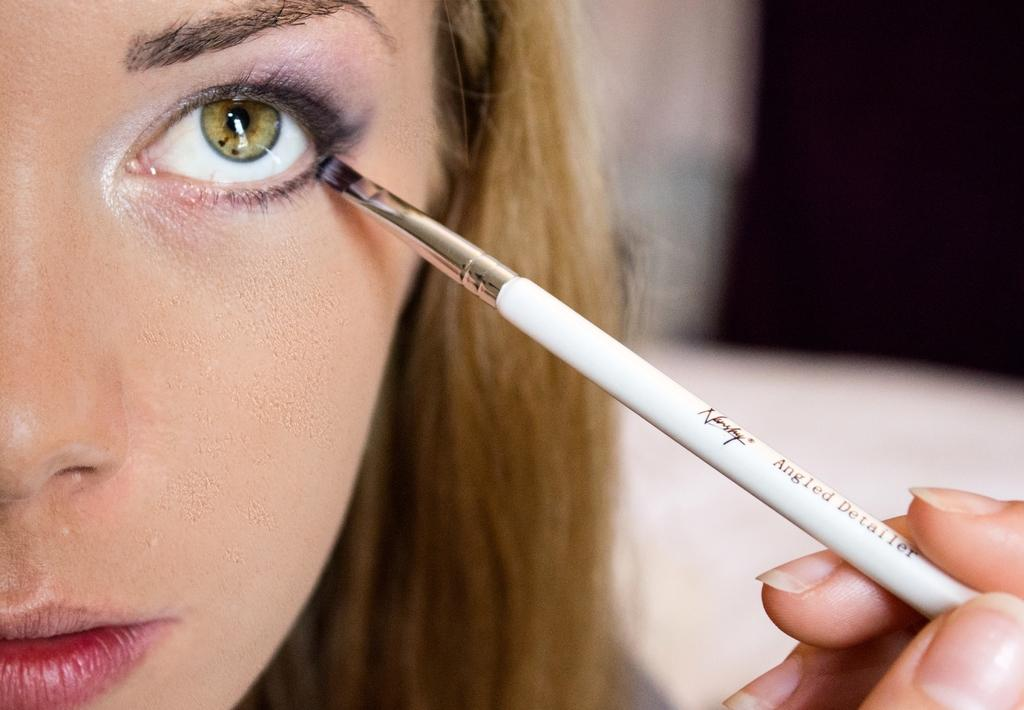Who is present in the image? There is a woman in the image. What object can be seen in the image? There is a makeup brush in the image. Can you describe the background of the image? The background of the image is blurry. How many boats can be seen in the image? There are no boats present in the image. What type of hill is visible in the background of the image? There is no hill visible in the image, as the background is blurry. 